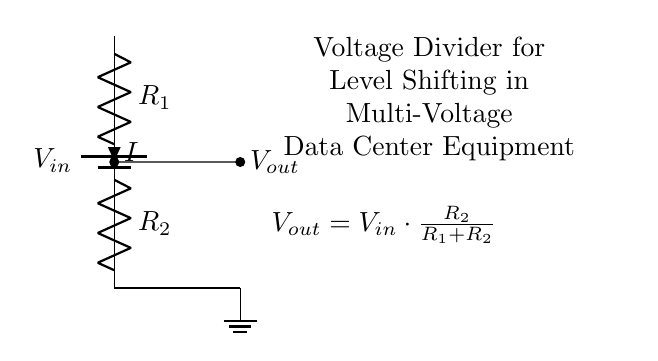What is the input voltage of the circuit? The input voltage is represented as V in the circuit diagram and is labeled as V in the circuit; the specific value isn't provided here, so it’s just V in general terms.
Answer: V What are the resistance values present in the circuit? The circuit diagram shows two resistors, R1 and R2. Their specific values are not indicated in the diagram, only their designation as R1 and R2.
Answer: R1 and R2 What is the output voltage formula in this circuit? The output voltage is calculated using the voltage divider formula, which is V out equals V in multiplied by R2 divided by the sum of R1 and R2. This relationship is explicitly stated in the circuit diagram.
Answer: V out = V in * (R2 / (R1 + R2)) What is the direction of current flow in this circuit? The current (I) flows downward through R1 and then through R2 to ground. This is indicated by the current notation pointing in the direction of flow from V in through R1 to R2 and finally to the ground.
Answer: Downward Why is this circuit used for level shifting in data center equipment? The voltage divider allows for reducing a higher input voltage (V in) to a lower output voltage (V out) suitable for level shifting which is essential when interfacing different voltage levels in data center equipment. This allows components with different operational voltage levels to communicate effectively.
Answer: For level shifting What is the function of R2 in the voltage divider? R2 determines the fraction of the input voltage that appears across it as output voltage (V out) according to the voltage divider formula, influencing how much voltage is shifted down to a lower level for use in circuit applications.
Answer: Determines V out 